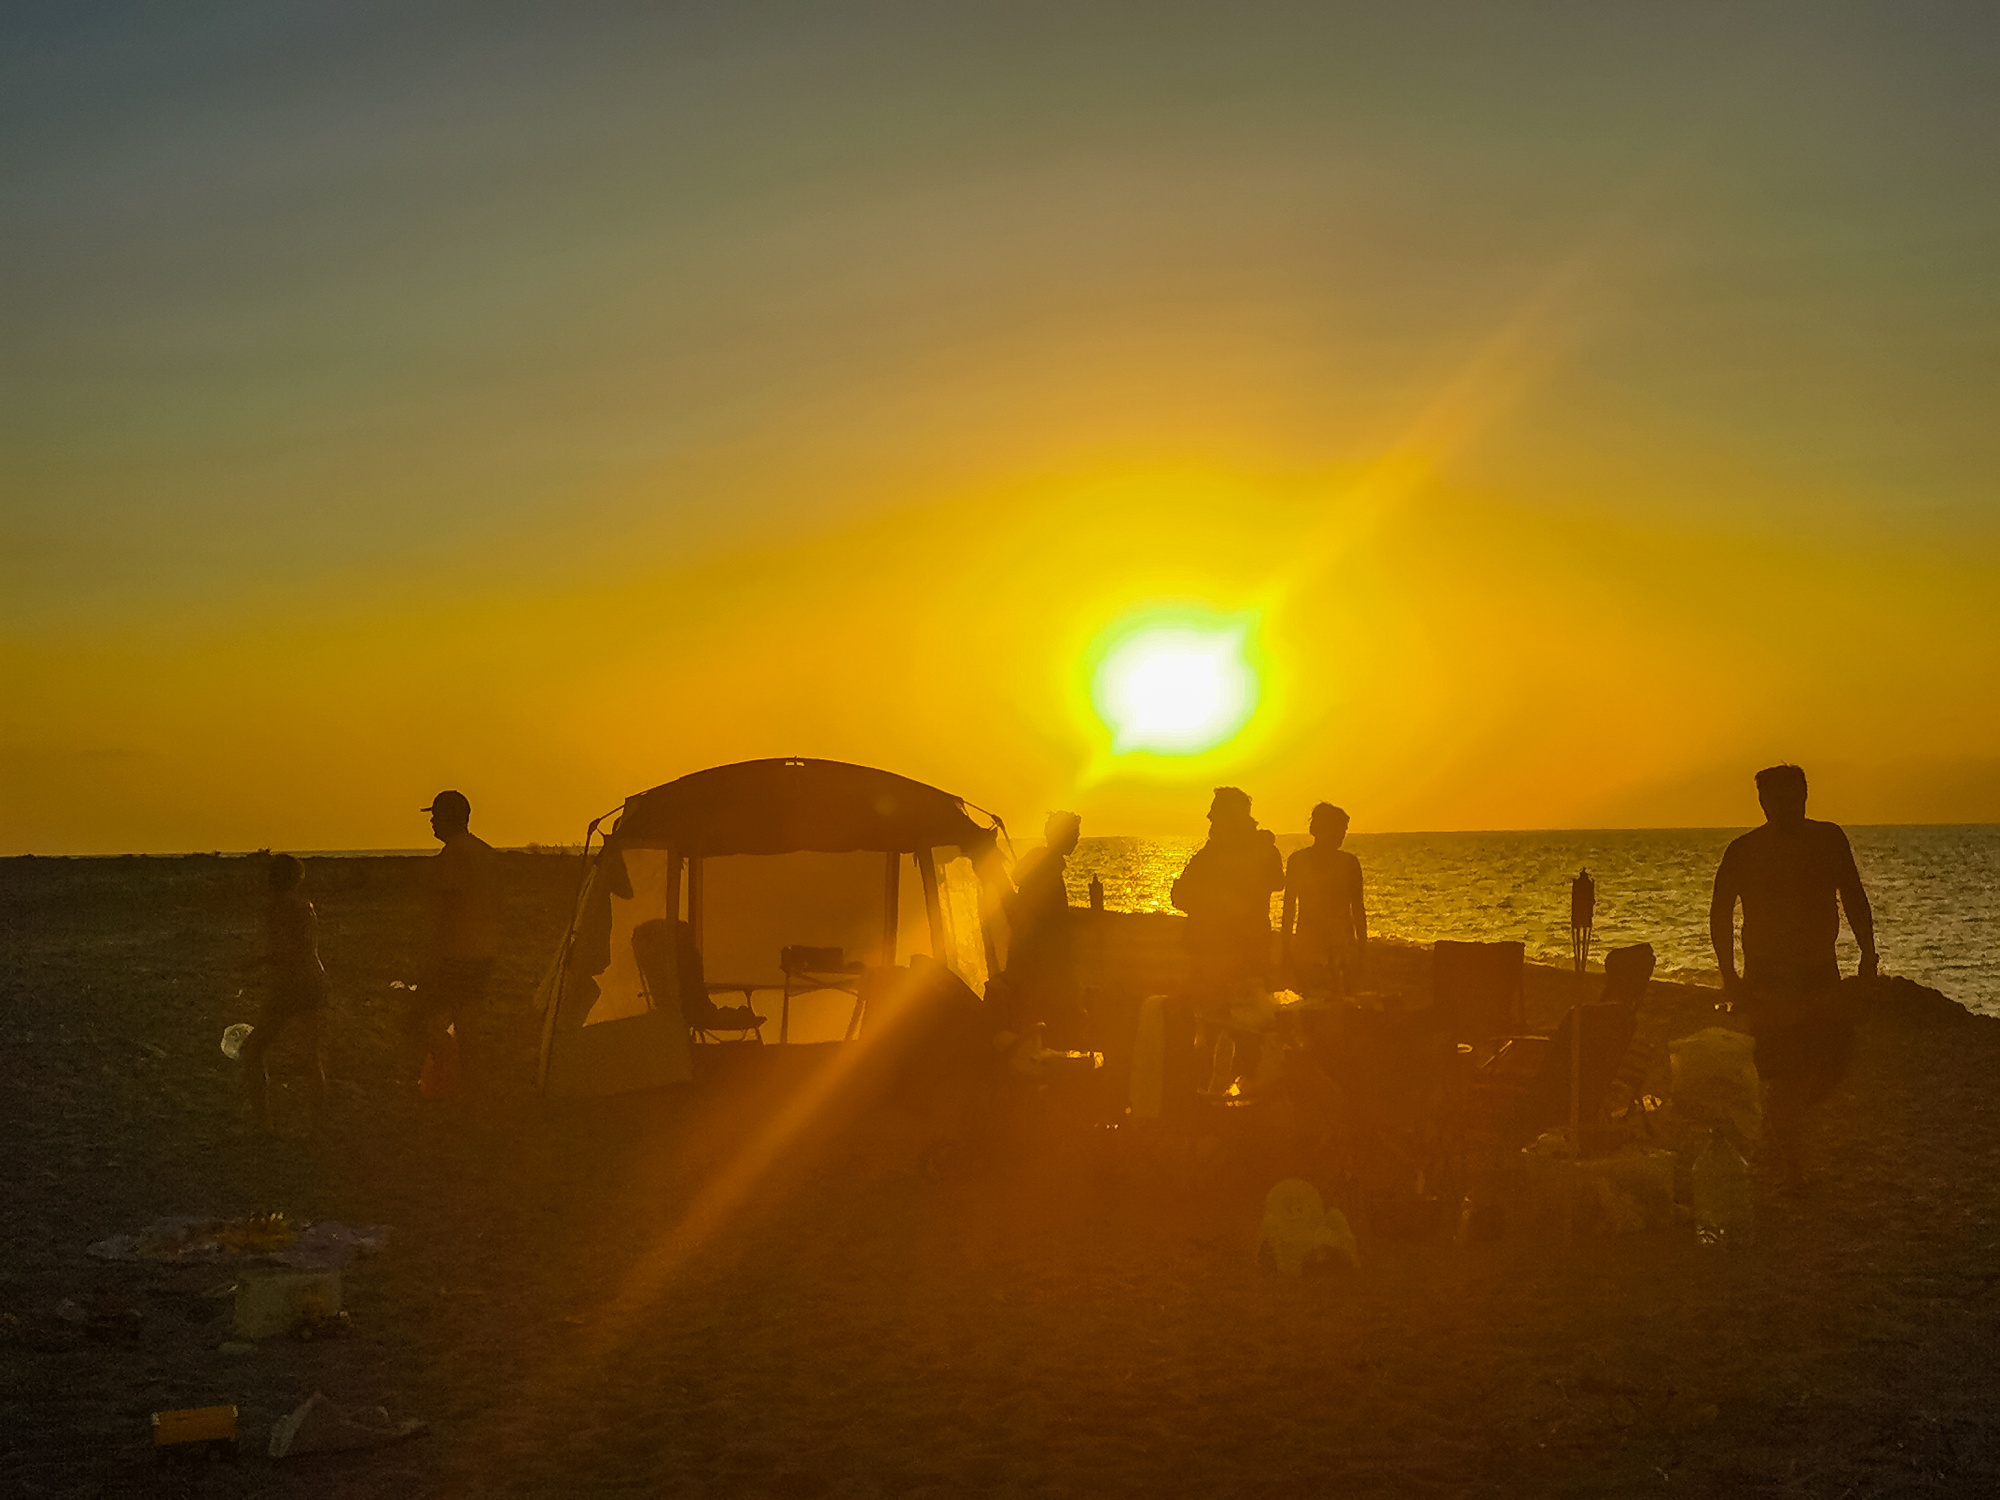What do you see happening in this image? The image depicts a tranquil evening by the shore, capturing the very moment the sun kisses the horizon goodnight. Shimmering with amber radiance, the sky is a canvas awash with orange splendor. Silhouetted figures pause their activities to admire the scene, spread around a shelter that promises respite after a day rich with the salty tang of sea adventures. The beach toys and equipment speak to a narrative of family outings and friendly gatherings, now winding down as day gives way to night. 